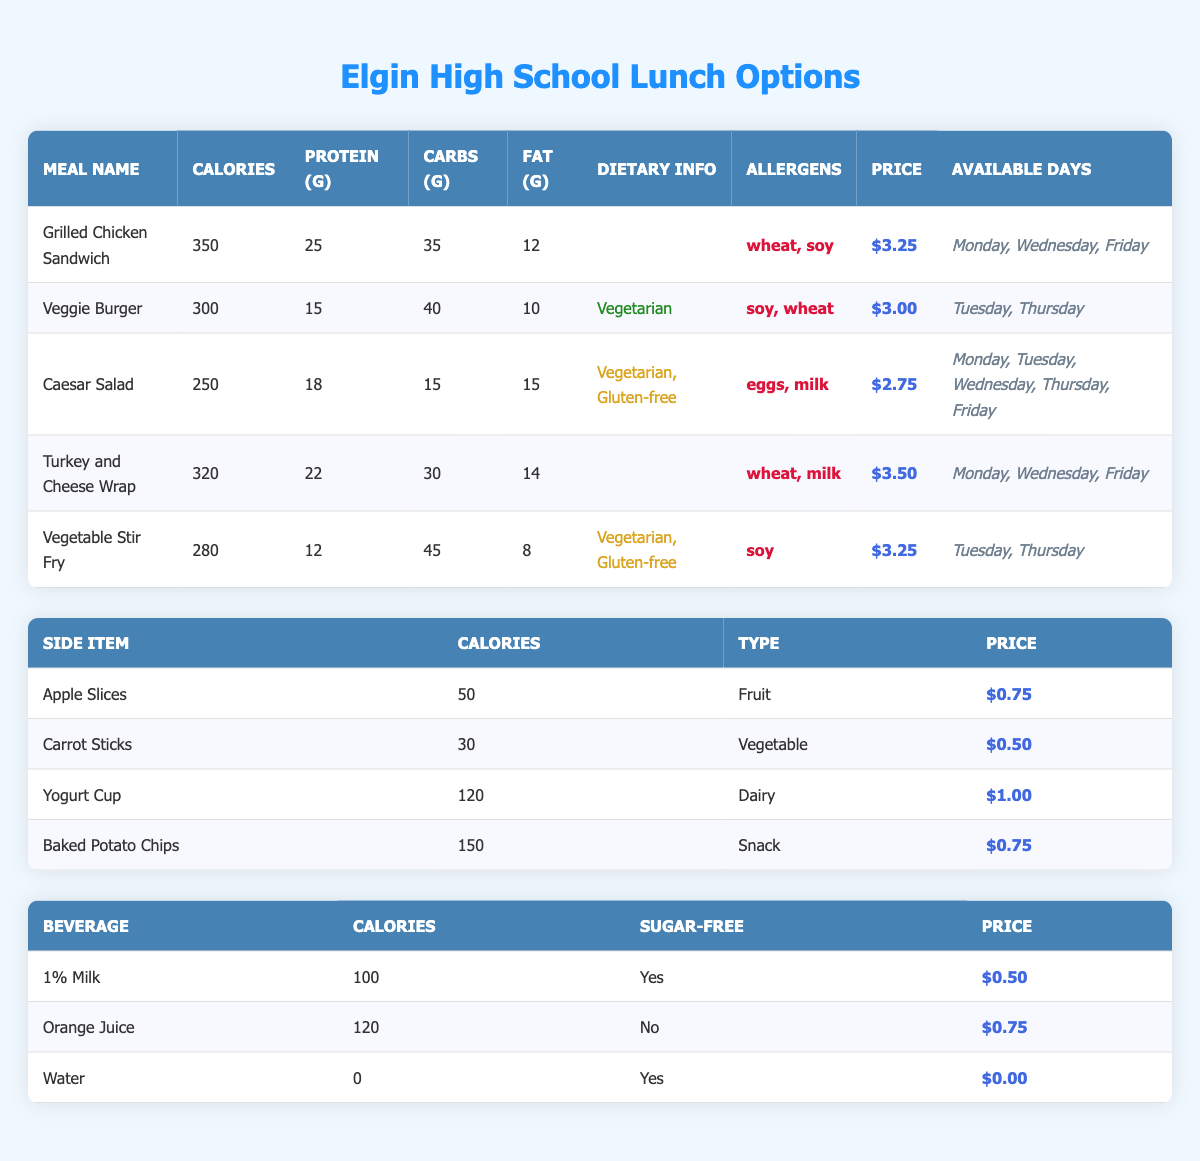What are the available days for the Grilled Chicken Sandwich? The table indicates that the Grilled Chicken Sandwich is available on Monday, Wednesday, and Friday.
Answer: Monday, Wednesday, Friday Which meal has the highest protein content? The protein grams for each meal are as follows: Grilled Chicken Sandwich (25g), Turkey and Cheese Wrap (22g), Caesar Salad (18g), Veggie Burger (15g), and Vegetable Stir Fry (12g). The Grilled Chicken Sandwich has the highest at 25g.
Answer: Grilled Chicken Sandwich Is the Caesar Salad gluten-free? In the table, the Caesar Salad is marked as gluten-free, meaning it does not contain gluten.
Answer: Yes What is the total calorie count for the Vegetable Stir Fry and the Veggie Burger? The calories for the Vegetable Stir Fry are 280, and the Veggie Burger is 300. Adding them together gives 280 + 300 = 580.
Answer: 580 How much more does the Turkey and Cheese Wrap cost compared to the Veggie Burger? The Turkey and Cheese Wrap costs $3.50, while the Veggie Burger costs $3.00. The difference is $3.50 - $3.00 = $0.50.
Answer: $0.50 What is the average calorie count of all the lunch options? The calorie counts of lunch options are 350, 300, 250, 320, and 280. The sum is 350 + 300 + 250 + 320 + 280 = 1500. There are 5 options, so the average is 1500 / 5 = 300.
Answer: 300 Does the Vegetable Stir Fry contain soy? The allergens listed for the Vegetable Stir Fry indicate that it contains soy.
Answer: Yes Which beverage option is both sugar-free and lowest in calories? The drink options are 1% Milk (100 calories), Orange Juice (120 calories), and Water (0 calories). Water is sugar-free and has the lowest calories at 0.
Answer: Water 